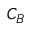Convert formula to latex. <formula><loc_0><loc_0><loc_500><loc_500>C _ { B }</formula> 